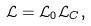Convert formula to latex. <formula><loc_0><loc_0><loc_500><loc_500>\mathcal { L } = \mathcal { L } _ { 0 } \mathcal { L } _ { C } ,</formula> 